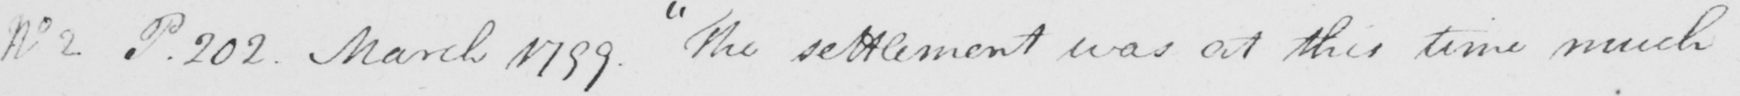What is written in this line of handwriting? No 2 . P . 202 . March 1799 . The settlement was at this time much 